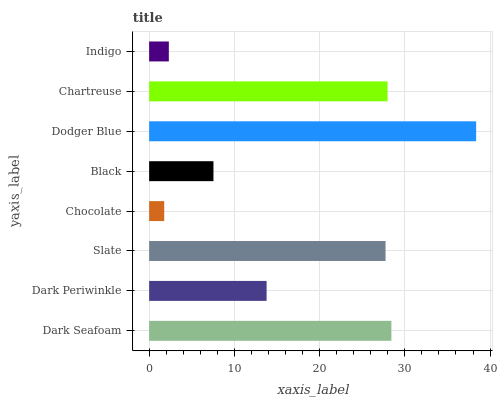Is Chocolate the minimum?
Answer yes or no. Yes. Is Dodger Blue the maximum?
Answer yes or no. Yes. Is Dark Periwinkle the minimum?
Answer yes or no. No. Is Dark Periwinkle the maximum?
Answer yes or no. No. Is Dark Seafoam greater than Dark Periwinkle?
Answer yes or no. Yes. Is Dark Periwinkle less than Dark Seafoam?
Answer yes or no. Yes. Is Dark Periwinkle greater than Dark Seafoam?
Answer yes or no. No. Is Dark Seafoam less than Dark Periwinkle?
Answer yes or no. No. Is Slate the high median?
Answer yes or no. Yes. Is Dark Periwinkle the low median?
Answer yes or no. Yes. Is Dark Seafoam the high median?
Answer yes or no. No. Is Chocolate the low median?
Answer yes or no. No. 